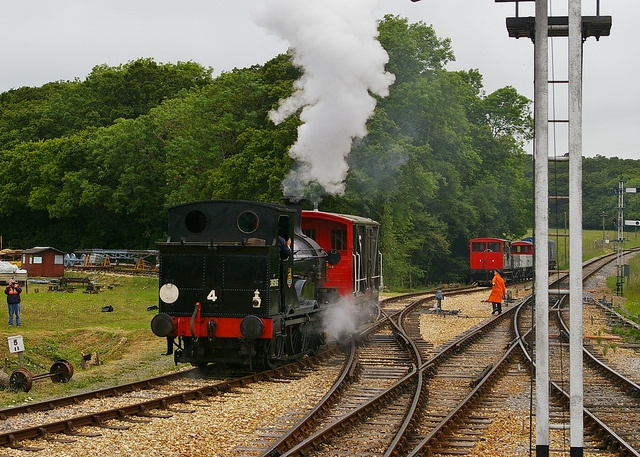Describe the objects in this image and their specific colors. I can see train in lightgray, black, gray, and maroon tones, train in lightgray, black, brown, gray, and maroon tones, people in lightgray, black, navy, gray, and blue tones, people in lightgray, red, black, and brown tones, and people in lightgray, black, and gray tones in this image. 